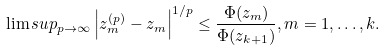<formula> <loc_0><loc_0><loc_500><loc_500>\lim s u p _ { p \to \infty } \left | z ^ { ( p ) } _ { m } - z _ { m } \right | ^ { 1 / p } \leq \frac { \Phi ( z _ { m } ) } { \Phi ( z _ { k + 1 } ) } , m = 1 , \dots , k .</formula> 